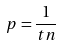Convert formula to latex. <formula><loc_0><loc_0><loc_500><loc_500>p = \frac { 1 } { t n }</formula> 